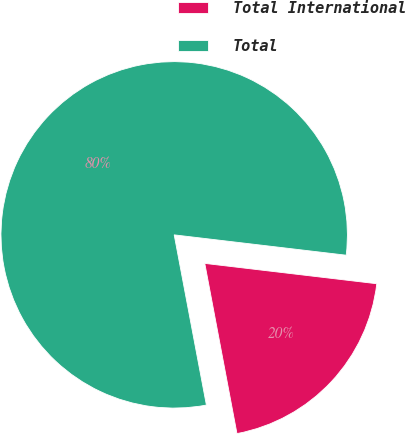Convert chart. <chart><loc_0><loc_0><loc_500><loc_500><pie_chart><fcel>Total International<fcel>Total<nl><fcel>20.15%<fcel>79.85%<nl></chart> 